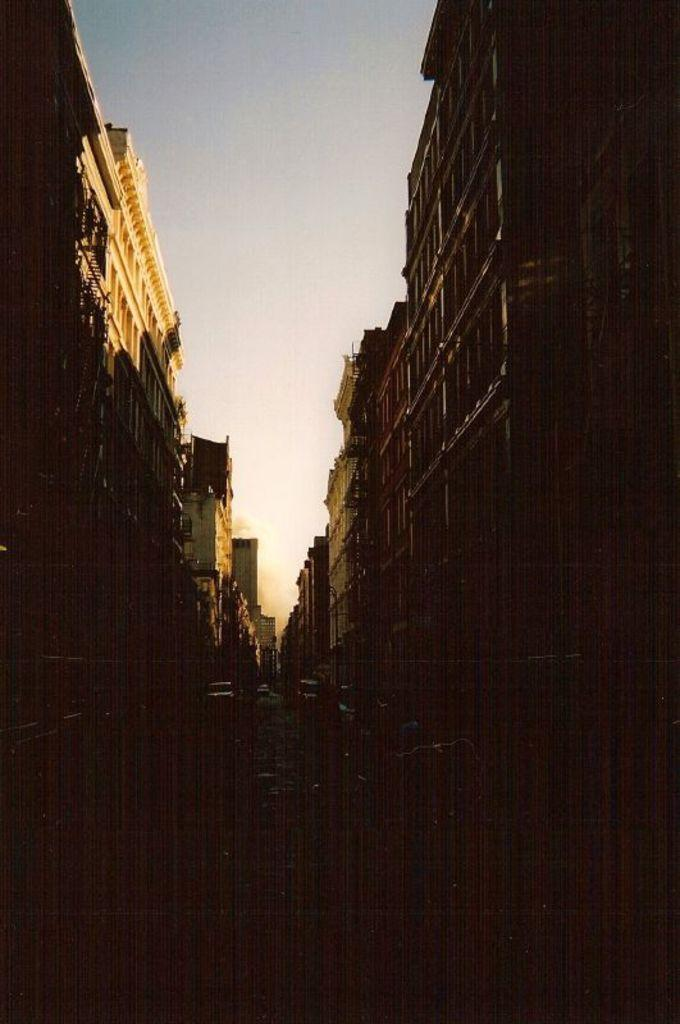What structures are located on both sides of the image? There are buildings on both sides of the image. What is in the middle of the image? There is a road in the center of the image. What can be seen on the road? There are vehicles on the road. What is visible at the top of the image? The sky is visible at the top of the image. How many turkeys can be seen walking on the road in the image? There are no turkeys present in the image; it features a road with vehicles. What type of lizards can be seen crawling on the buildings in the image? There are no lizards present in the image; it features buildings and a road with vehicles. 